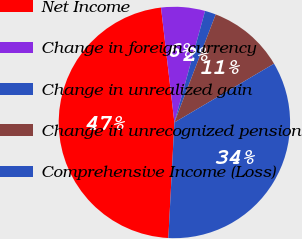Convert chart to OTSL. <chart><loc_0><loc_0><loc_500><loc_500><pie_chart><fcel>Net Income<fcel>Change in foreign currency<fcel>Change in unrealized gain<fcel>Change in unrecognized pension<fcel>Comprehensive Income (Loss)<nl><fcel>47.32%<fcel>6.12%<fcel>1.54%<fcel>10.7%<fcel>34.31%<nl></chart> 